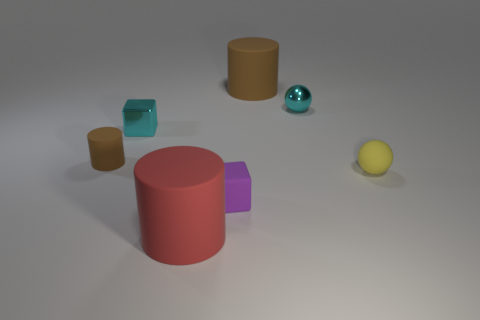What number of large things are either yellow rubber balls or cyan matte things?
Give a very brief answer. 0. Are there an equal number of large brown objects to the right of the yellow rubber object and tiny metal cylinders?
Offer a terse response. Yes. Are there any cyan metal objects right of the large brown matte object?
Your answer should be very brief. Yes. How many metallic things are either large brown cylinders or yellow balls?
Provide a succinct answer. 0. How many tiny things are left of the tiny brown cylinder?
Your response must be concise. 0. Are there any rubber objects that have the same size as the cyan metal ball?
Provide a succinct answer. Yes. Are there any small matte things that have the same color as the tiny shiny block?
Your answer should be very brief. No. Is there anything else that is the same size as the cyan shiny sphere?
Give a very brief answer. Yes. How many small metallic cubes have the same color as the tiny shiny ball?
Offer a terse response. 1. There is a rubber cube; does it have the same color as the shiny object left of the small cyan ball?
Ensure brevity in your answer.  No. 